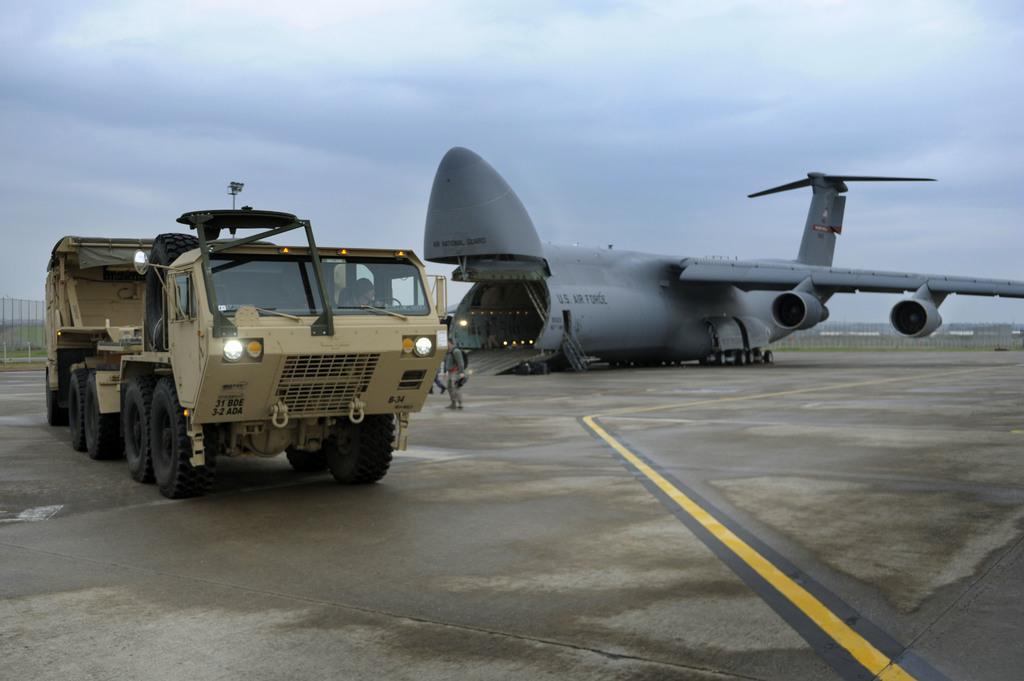Can you describe this image briefly? In this image, we can see a truck and aeroplane is placed on the surface. Here we can see a person is inside the vehicle and two people are here. Background we can see fencing, grass and sky. 